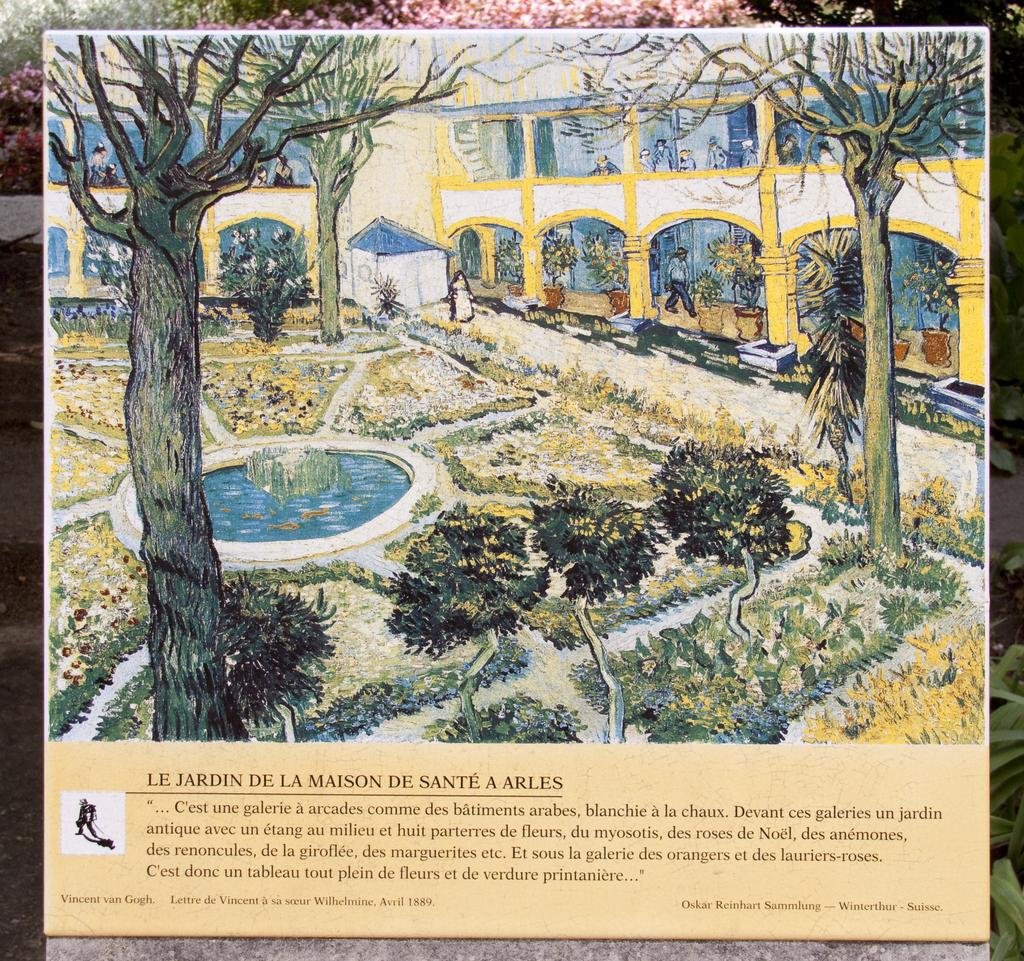What type of visual representation is shown in the image? The image is a poster. What can be seen in the poster? There are depictions of people, buildings, and a pond in the image. Is there any text present in the image? Yes, there is some text at the bottom of the image. How many sheep are visible in the image? There are no sheep present in the image. What type of wood is used to create the buildings in the image? The image is a poster, not a photograph or a real-life scene, so it does not depict actual wood used in the construction of the buildings. 